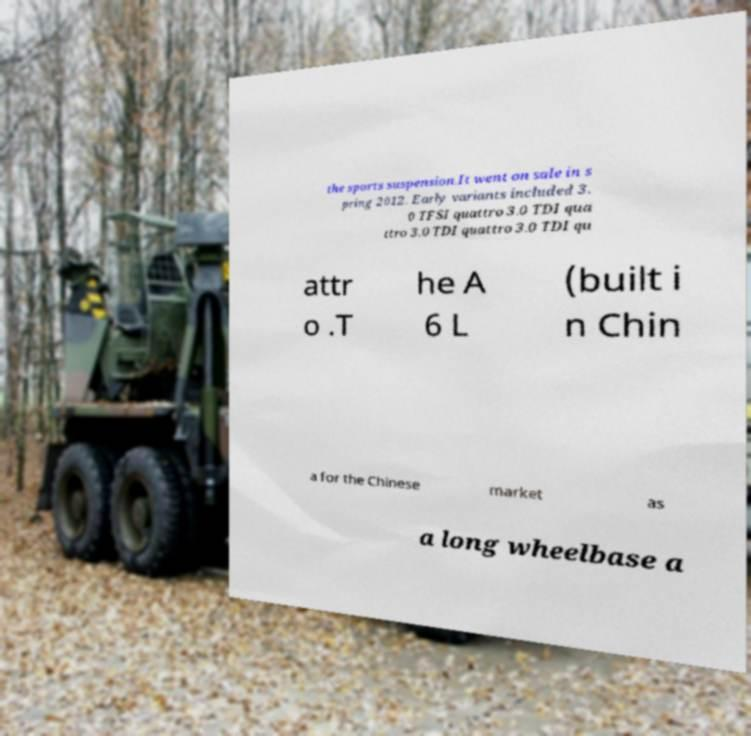For documentation purposes, I need the text within this image transcribed. Could you provide that? the sports suspension.It went on sale in s pring 2012. Early variants included 3. 0 TFSI quattro 3.0 TDI qua ttro 3.0 TDI quattro 3.0 TDI qu attr o .T he A 6 L (built i n Chin a for the Chinese market as a long wheelbase a 